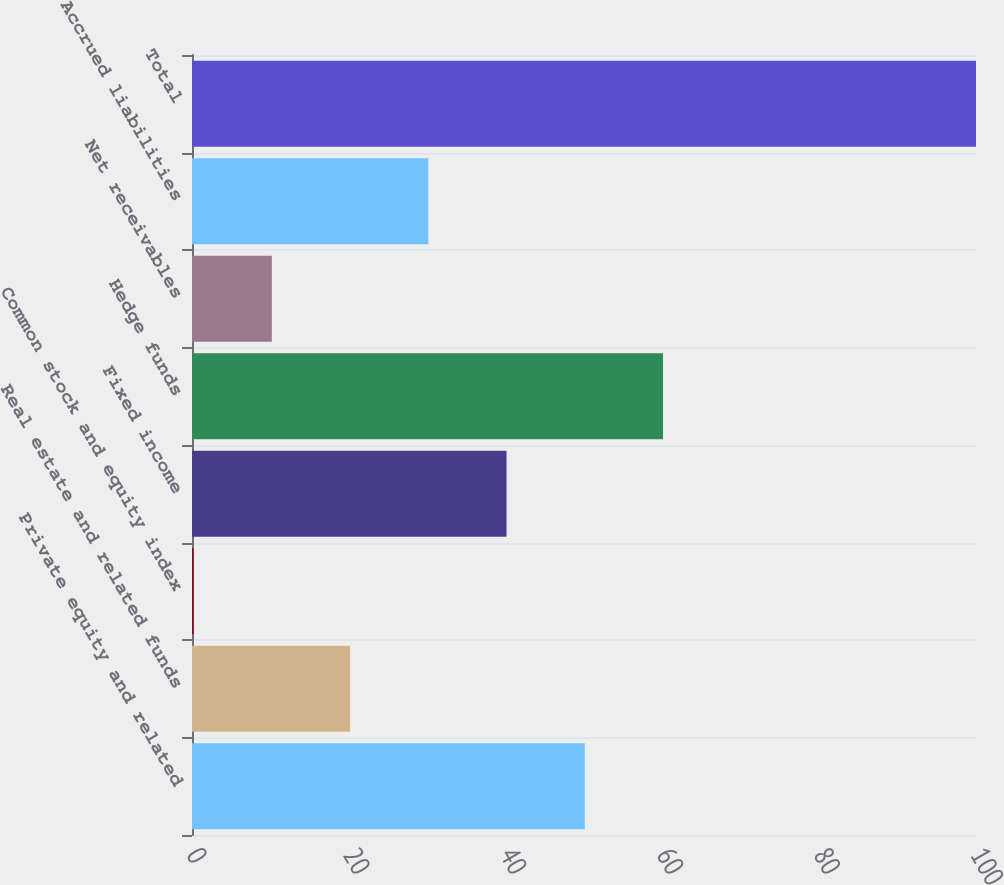Convert chart. <chart><loc_0><loc_0><loc_500><loc_500><bar_chart><fcel>Private equity and related<fcel>Real estate and related funds<fcel>Common stock and equity index<fcel>Fixed income<fcel>Hedge funds<fcel>Net receivables<fcel>Accrued liabilities<fcel>Total<nl><fcel>50.1<fcel>20.16<fcel>0.2<fcel>40.12<fcel>60.08<fcel>10.18<fcel>30.14<fcel>100<nl></chart> 